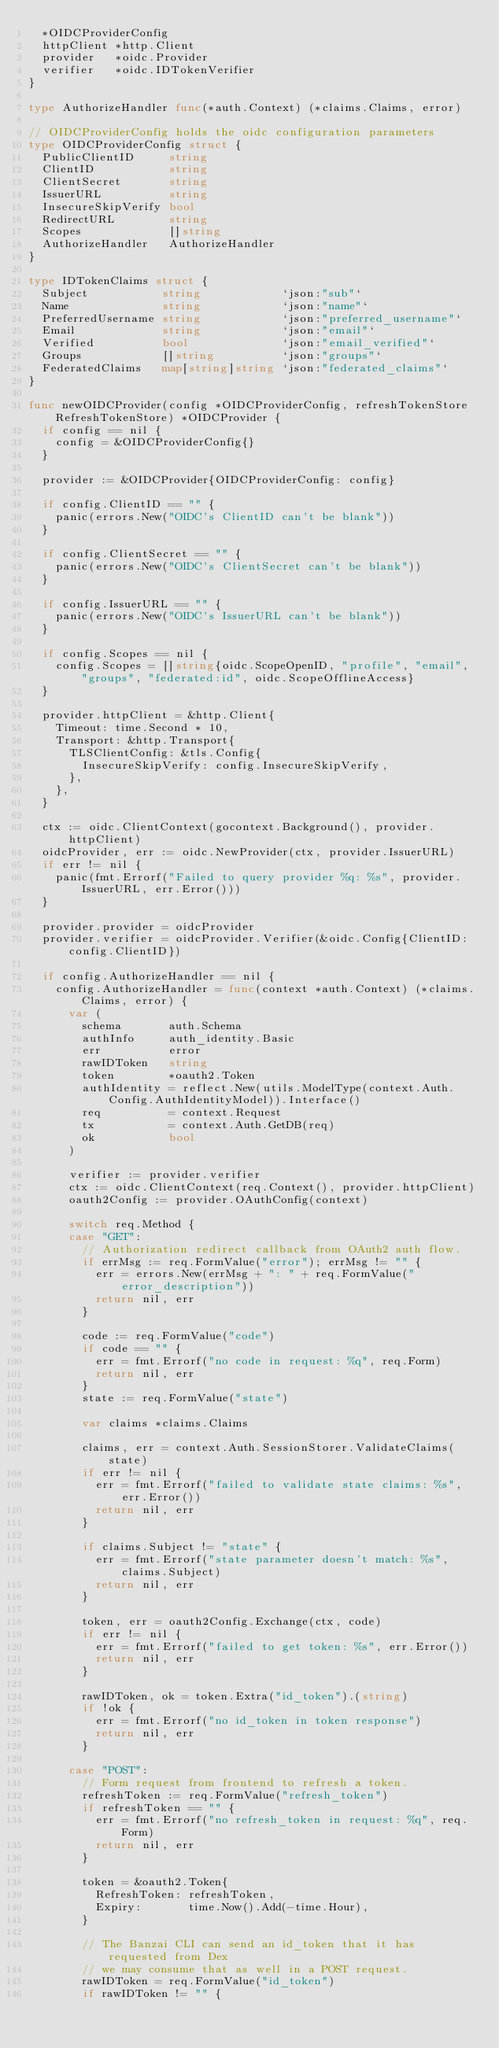<code> <loc_0><loc_0><loc_500><loc_500><_Go_>	*OIDCProviderConfig
	httpClient *http.Client
	provider   *oidc.Provider
	verifier   *oidc.IDTokenVerifier
}

type AuthorizeHandler func(*auth.Context) (*claims.Claims, error)

// OIDCProviderConfig holds the oidc configuration parameters
type OIDCProviderConfig struct {
	PublicClientID     string
	ClientID           string
	ClientSecret       string
	IssuerURL          string
	InsecureSkipVerify bool
	RedirectURL        string
	Scopes             []string
	AuthorizeHandler   AuthorizeHandler
}

type IDTokenClaims struct {
	Subject           string            `json:"sub"`
	Name              string            `json:"name"`
	PreferredUsername string            `json:"preferred_username"`
	Email             string            `json:"email"`
	Verified          bool              `json:"email_verified"`
	Groups            []string          `json:"groups"`
	FederatedClaims   map[string]string `json:"federated_claims"`
}

func newOIDCProvider(config *OIDCProviderConfig, refreshTokenStore RefreshTokenStore) *OIDCProvider {
	if config == nil {
		config = &OIDCProviderConfig{}
	}

	provider := &OIDCProvider{OIDCProviderConfig: config}

	if config.ClientID == "" {
		panic(errors.New("OIDC's ClientID can't be blank"))
	}

	if config.ClientSecret == "" {
		panic(errors.New("OIDC's ClientSecret can't be blank"))
	}

	if config.IssuerURL == "" {
		panic(errors.New("OIDC's IssuerURL can't be blank"))
	}

	if config.Scopes == nil {
		config.Scopes = []string{oidc.ScopeOpenID, "profile", "email", "groups", "federated:id", oidc.ScopeOfflineAccess}
	}

	provider.httpClient = &http.Client{
		Timeout: time.Second * 10,
		Transport: &http.Transport{
			TLSClientConfig: &tls.Config{
				InsecureSkipVerify: config.InsecureSkipVerify,
			},
		},
	}

	ctx := oidc.ClientContext(gocontext.Background(), provider.httpClient)
	oidcProvider, err := oidc.NewProvider(ctx, provider.IssuerURL)
	if err != nil {
		panic(fmt.Errorf("Failed to query provider %q: %s", provider.IssuerURL, err.Error()))
	}

	provider.provider = oidcProvider
	provider.verifier = oidcProvider.Verifier(&oidc.Config{ClientID: config.ClientID})

	if config.AuthorizeHandler == nil {
		config.AuthorizeHandler = func(context *auth.Context) (*claims.Claims, error) {
			var (
				schema       auth.Schema
				authInfo     auth_identity.Basic
				err          error
				rawIDToken   string
				token        *oauth2.Token
				authIdentity = reflect.New(utils.ModelType(context.Auth.Config.AuthIdentityModel)).Interface()
				req          = context.Request
				tx           = context.Auth.GetDB(req)
				ok           bool
			)

			verifier := provider.verifier
			ctx := oidc.ClientContext(req.Context(), provider.httpClient)
			oauth2Config := provider.OAuthConfig(context)

			switch req.Method {
			case "GET":
				// Authorization redirect callback from OAuth2 auth flow.
				if errMsg := req.FormValue("error"); errMsg != "" {
					err = errors.New(errMsg + ": " + req.FormValue("error_description"))
					return nil, err
				}

				code := req.FormValue("code")
				if code == "" {
					err = fmt.Errorf("no code in request: %q", req.Form)
					return nil, err
				}
				state := req.FormValue("state")

				var claims *claims.Claims

				claims, err = context.Auth.SessionStorer.ValidateClaims(state)
				if err != nil {
					err = fmt.Errorf("failed to validate state claims: %s", err.Error())
					return nil, err
				}

				if claims.Subject != "state" {
					err = fmt.Errorf("state parameter doesn't match: %s", claims.Subject)
					return nil, err
				}

				token, err = oauth2Config.Exchange(ctx, code)
				if err != nil {
					err = fmt.Errorf("failed to get token: %s", err.Error())
					return nil, err
				}

				rawIDToken, ok = token.Extra("id_token").(string)
				if !ok {
					err = fmt.Errorf("no id_token in token response")
					return nil, err
				}

			case "POST":
				// Form request from frontend to refresh a token.
				refreshToken := req.FormValue("refresh_token")
				if refreshToken == "" {
					err = fmt.Errorf("no refresh_token in request: %q", req.Form)
					return nil, err
				}

				token = &oauth2.Token{
					RefreshToken: refreshToken,
					Expiry:       time.Now().Add(-time.Hour),
				}

				// The Banzai CLI can send an id_token that it has requested from Dex
				// we may consume that as well in a POST request.
				rawIDToken = req.FormValue("id_token")
				if rawIDToken != "" {</code> 